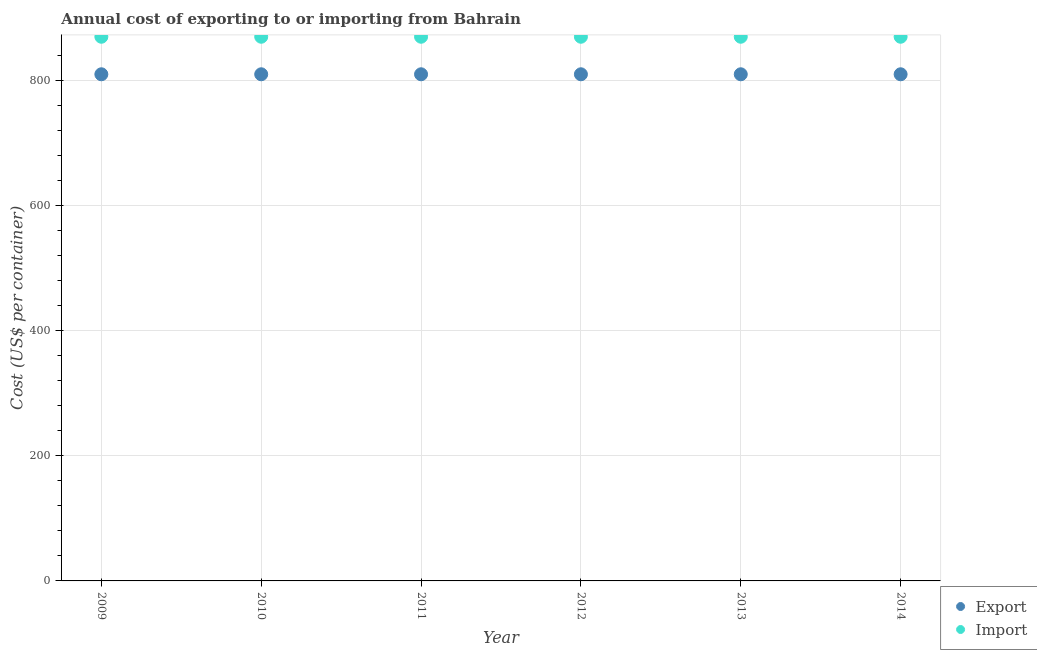How many different coloured dotlines are there?
Your answer should be compact. 2. Is the number of dotlines equal to the number of legend labels?
Your response must be concise. Yes. What is the import cost in 2013?
Your response must be concise. 870. Across all years, what is the maximum export cost?
Provide a short and direct response. 810. Across all years, what is the minimum export cost?
Ensure brevity in your answer.  810. In which year was the import cost maximum?
Your answer should be very brief. 2009. What is the total import cost in the graph?
Your answer should be compact. 5220. What is the difference between the import cost in 2013 and the export cost in 2009?
Ensure brevity in your answer.  60. What is the average import cost per year?
Offer a terse response. 870. In the year 2013, what is the difference between the import cost and export cost?
Your answer should be very brief. 60. What is the difference between the highest and the second highest export cost?
Provide a short and direct response. 0. What is the difference between the highest and the lowest import cost?
Offer a very short reply. 0. Is the import cost strictly greater than the export cost over the years?
Provide a short and direct response. Yes. Is the export cost strictly less than the import cost over the years?
Make the answer very short. Yes. How many dotlines are there?
Ensure brevity in your answer.  2. How many years are there in the graph?
Provide a short and direct response. 6. What is the difference between two consecutive major ticks on the Y-axis?
Your answer should be compact. 200. Are the values on the major ticks of Y-axis written in scientific E-notation?
Provide a succinct answer. No. Does the graph contain any zero values?
Offer a very short reply. No. Where does the legend appear in the graph?
Provide a short and direct response. Bottom right. What is the title of the graph?
Ensure brevity in your answer.  Annual cost of exporting to or importing from Bahrain. What is the label or title of the X-axis?
Offer a terse response. Year. What is the label or title of the Y-axis?
Your answer should be very brief. Cost (US$ per container). What is the Cost (US$ per container) of Export in 2009?
Provide a short and direct response. 810. What is the Cost (US$ per container) in Import in 2009?
Offer a terse response. 870. What is the Cost (US$ per container) in Export in 2010?
Your response must be concise. 810. What is the Cost (US$ per container) of Import in 2010?
Make the answer very short. 870. What is the Cost (US$ per container) in Export in 2011?
Your answer should be very brief. 810. What is the Cost (US$ per container) in Import in 2011?
Provide a short and direct response. 870. What is the Cost (US$ per container) of Export in 2012?
Your response must be concise. 810. What is the Cost (US$ per container) of Import in 2012?
Keep it short and to the point. 870. What is the Cost (US$ per container) of Export in 2013?
Offer a terse response. 810. What is the Cost (US$ per container) of Import in 2013?
Offer a very short reply. 870. What is the Cost (US$ per container) in Export in 2014?
Provide a short and direct response. 810. What is the Cost (US$ per container) in Import in 2014?
Provide a short and direct response. 870. Across all years, what is the maximum Cost (US$ per container) in Export?
Your answer should be very brief. 810. Across all years, what is the maximum Cost (US$ per container) of Import?
Provide a succinct answer. 870. Across all years, what is the minimum Cost (US$ per container) in Export?
Provide a short and direct response. 810. Across all years, what is the minimum Cost (US$ per container) of Import?
Offer a very short reply. 870. What is the total Cost (US$ per container) in Export in the graph?
Provide a short and direct response. 4860. What is the total Cost (US$ per container) of Import in the graph?
Ensure brevity in your answer.  5220. What is the difference between the Cost (US$ per container) in Export in 2009 and that in 2010?
Your answer should be very brief. 0. What is the difference between the Cost (US$ per container) of Import in 2009 and that in 2010?
Make the answer very short. 0. What is the difference between the Cost (US$ per container) of Export in 2009 and that in 2011?
Make the answer very short. 0. What is the difference between the Cost (US$ per container) in Export in 2009 and that in 2013?
Your answer should be compact. 0. What is the difference between the Cost (US$ per container) of Export in 2010 and that in 2011?
Provide a short and direct response. 0. What is the difference between the Cost (US$ per container) in Import in 2010 and that in 2011?
Keep it short and to the point. 0. What is the difference between the Cost (US$ per container) in Export in 2010 and that in 2012?
Offer a very short reply. 0. What is the difference between the Cost (US$ per container) of Import in 2010 and that in 2012?
Provide a succinct answer. 0. What is the difference between the Cost (US$ per container) of Import in 2010 and that in 2013?
Your response must be concise. 0. What is the difference between the Cost (US$ per container) of Import in 2010 and that in 2014?
Provide a short and direct response. 0. What is the difference between the Cost (US$ per container) in Export in 2011 and that in 2012?
Your answer should be very brief. 0. What is the difference between the Cost (US$ per container) in Export in 2011 and that in 2013?
Ensure brevity in your answer.  0. What is the difference between the Cost (US$ per container) in Export in 2011 and that in 2014?
Your answer should be very brief. 0. What is the difference between the Cost (US$ per container) in Import in 2012 and that in 2013?
Ensure brevity in your answer.  0. What is the difference between the Cost (US$ per container) of Import in 2013 and that in 2014?
Offer a terse response. 0. What is the difference between the Cost (US$ per container) of Export in 2009 and the Cost (US$ per container) of Import in 2010?
Your answer should be compact. -60. What is the difference between the Cost (US$ per container) of Export in 2009 and the Cost (US$ per container) of Import in 2011?
Keep it short and to the point. -60. What is the difference between the Cost (US$ per container) in Export in 2009 and the Cost (US$ per container) in Import in 2012?
Your answer should be very brief. -60. What is the difference between the Cost (US$ per container) in Export in 2009 and the Cost (US$ per container) in Import in 2013?
Offer a terse response. -60. What is the difference between the Cost (US$ per container) in Export in 2009 and the Cost (US$ per container) in Import in 2014?
Give a very brief answer. -60. What is the difference between the Cost (US$ per container) of Export in 2010 and the Cost (US$ per container) of Import in 2011?
Your answer should be compact. -60. What is the difference between the Cost (US$ per container) of Export in 2010 and the Cost (US$ per container) of Import in 2012?
Your answer should be very brief. -60. What is the difference between the Cost (US$ per container) in Export in 2010 and the Cost (US$ per container) in Import in 2013?
Offer a very short reply. -60. What is the difference between the Cost (US$ per container) of Export in 2010 and the Cost (US$ per container) of Import in 2014?
Offer a very short reply. -60. What is the difference between the Cost (US$ per container) of Export in 2011 and the Cost (US$ per container) of Import in 2012?
Offer a terse response. -60. What is the difference between the Cost (US$ per container) of Export in 2011 and the Cost (US$ per container) of Import in 2013?
Provide a succinct answer. -60. What is the difference between the Cost (US$ per container) in Export in 2011 and the Cost (US$ per container) in Import in 2014?
Provide a succinct answer. -60. What is the difference between the Cost (US$ per container) in Export in 2012 and the Cost (US$ per container) in Import in 2013?
Give a very brief answer. -60. What is the difference between the Cost (US$ per container) of Export in 2012 and the Cost (US$ per container) of Import in 2014?
Offer a very short reply. -60. What is the difference between the Cost (US$ per container) of Export in 2013 and the Cost (US$ per container) of Import in 2014?
Give a very brief answer. -60. What is the average Cost (US$ per container) in Export per year?
Provide a succinct answer. 810. What is the average Cost (US$ per container) in Import per year?
Ensure brevity in your answer.  870. In the year 2009, what is the difference between the Cost (US$ per container) in Export and Cost (US$ per container) in Import?
Offer a terse response. -60. In the year 2010, what is the difference between the Cost (US$ per container) in Export and Cost (US$ per container) in Import?
Provide a succinct answer. -60. In the year 2011, what is the difference between the Cost (US$ per container) of Export and Cost (US$ per container) of Import?
Make the answer very short. -60. In the year 2012, what is the difference between the Cost (US$ per container) in Export and Cost (US$ per container) in Import?
Offer a terse response. -60. In the year 2013, what is the difference between the Cost (US$ per container) of Export and Cost (US$ per container) of Import?
Your answer should be compact. -60. In the year 2014, what is the difference between the Cost (US$ per container) of Export and Cost (US$ per container) of Import?
Provide a short and direct response. -60. What is the ratio of the Cost (US$ per container) in Export in 2009 to that in 2010?
Your answer should be compact. 1. What is the ratio of the Cost (US$ per container) in Import in 2009 to that in 2010?
Make the answer very short. 1. What is the ratio of the Cost (US$ per container) of Export in 2009 to that in 2011?
Your answer should be very brief. 1. What is the ratio of the Cost (US$ per container) of Export in 2009 to that in 2012?
Give a very brief answer. 1. What is the ratio of the Cost (US$ per container) in Export in 2009 to that in 2013?
Your answer should be very brief. 1. What is the ratio of the Cost (US$ per container) in Import in 2009 to that in 2013?
Provide a short and direct response. 1. What is the ratio of the Cost (US$ per container) in Import in 2010 to that in 2011?
Your answer should be compact. 1. What is the ratio of the Cost (US$ per container) in Export in 2010 to that in 2012?
Ensure brevity in your answer.  1. What is the ratio of the Cost (US$ per container) in Export in 2010 to that in 2014?
Provide a short and direct response. 1. What is the ratio of the Cost (US$ per container) in Import in 2010 to that in 2014?
Your answer should be compact. 1. What is the ratio of the Cost (US$ per container) of Export in 2011 to that in 2012?
Your answer should be very brief. 1. What is the ratio of the Cost (US$ per container) in Export in 2011 to that in 2014?
Keep it short and to the point. 1. What is the ratio of the Cost (US$ per container) of Import in 2011 to that in 2014?
Provide a succinct answer. 1. What is the ratio of the Cost (US$ per container) of Export in 2012 to that in 2014?
Ensure brevity in your answer.  1. What is the difference between the highest and the second highest Cost (US$ per container) in Import?
Keep it short and to the point. 0. What is the difference between the highest and the lowest Cost (US$ per container) of Export?
Your answer should be compact. 0. 